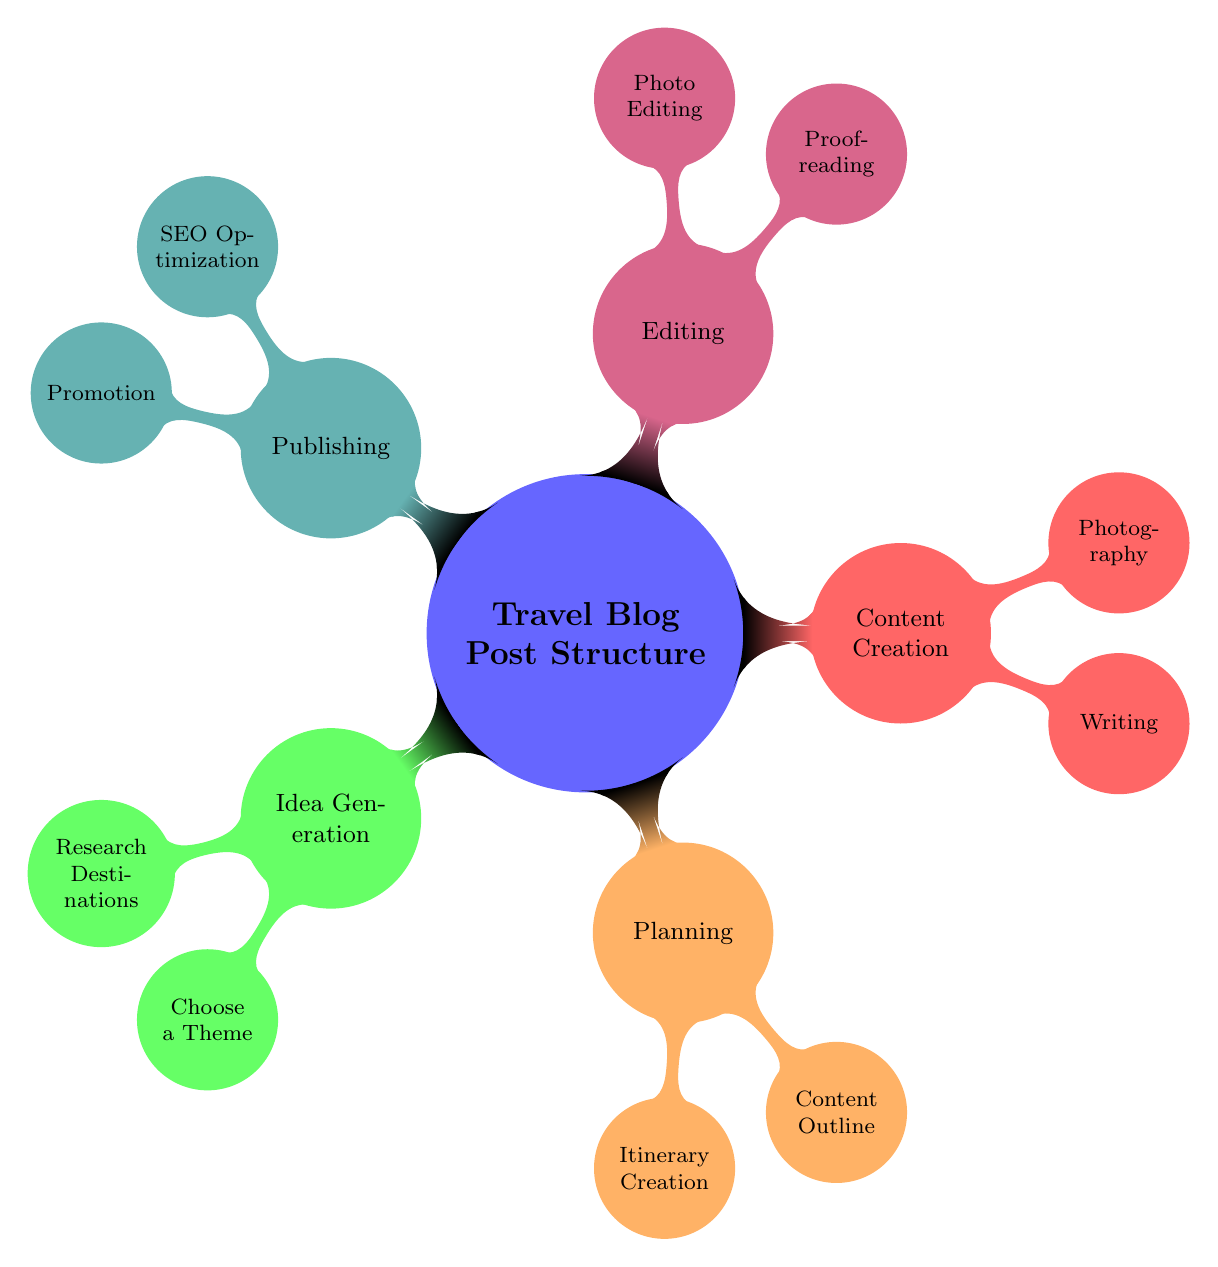What is the main central theme of the mind map? The central theme is indicated by the main node which states "Travel Blog Post Structure". This captures the overall topic and forms the basis for the entire mind map.
Answer: Travel Blog Post Structure How many main branches are there in the mind map? The diagram contains five main branches radiating from the central node: Idea Generation, Planning, Content Creation, Editing, and Publishing. Each of these represents a significant step in the blog post creation process.
Answer: Five What is one sub-node under 'Content Creation'? The sub-nodes under Content Creation are Writing and Photography. Either of these can be accurately cited as a sub-node.
Answer: Writing Which main branch focuses on preparing the content before posting? The Editing branch is specifically dedicated to improving the quality of the content by proofreading and photo editing, thus ensuring it meets standards before publishing.
Answer: Editing Which two areas are explored under 'Research Destinations'? The options listed under Research Destinations include "Search for lesser-known small towns" and "Find winter sports destinations", both of which are critical for generating ideas for travel content.
Answer: Search for lesser-known small towns and Find winter sports destinations What activities are highlighted in 'Content Outline'? The Content Outline indicates three areas of focus: "Introduction to the town", "Winter sports experiences", and "Local dining recommendations", which collectively shape the structure of the blog post.
Answer: Introduction to the town, Winter sports experiences, Local dining recommendations How is SEO addressed in the publishing phase? The publishing phase addresses SEO optimization through two main activities: "Keyword research" and "Meta descriptions and tags", which are essential for making the content discoverable online.
Answer: Keyword research and Meta descriptions and tags Which branch emphasizes sharing the blog post after publication? The Promotion sub-section under Publishing emphasizes actions like sharing on social media and engaging with travel communities to increase visibility after the post is published.
Answer: Promotion What are the two main tasks involved in proofreading? Proofreading encompasses checking for "grammar and spelling" and ensuring "clarity and flow", both crucial for refining the content.
Answer: Check for grammar and spelling and Ensure clarity and flow 